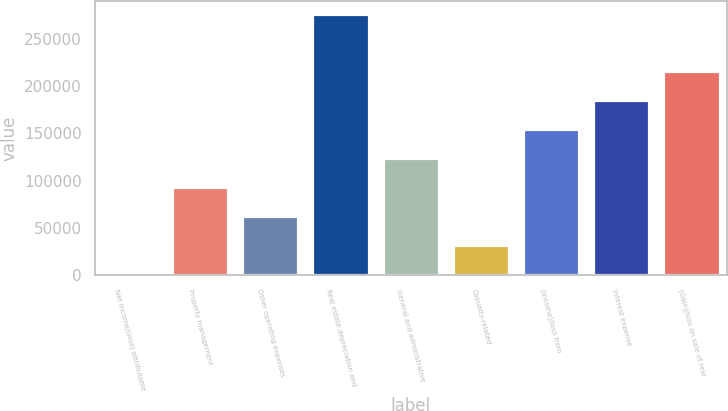<chart> <loc_0><loc_0><loc_500><loc_500><bar_chart><fcel>Net income/(loss) attributable<fcel>Property management<fcel>Other operating expenses<fcel>Real estate depreciation and<fcel>General and administrative<fcel>Casualty-related<fcel>(Income)/loss from<fcel>Interest expense<fcel>(Gain)/loss on sale of real<nl><fcel>1548<fcel>93135.9<fcel>62606.6<fcel>276312<fcel>123665<fcel>32077.3<fcel>154194<fcel>184724<fcel>215253<nl></chart> 